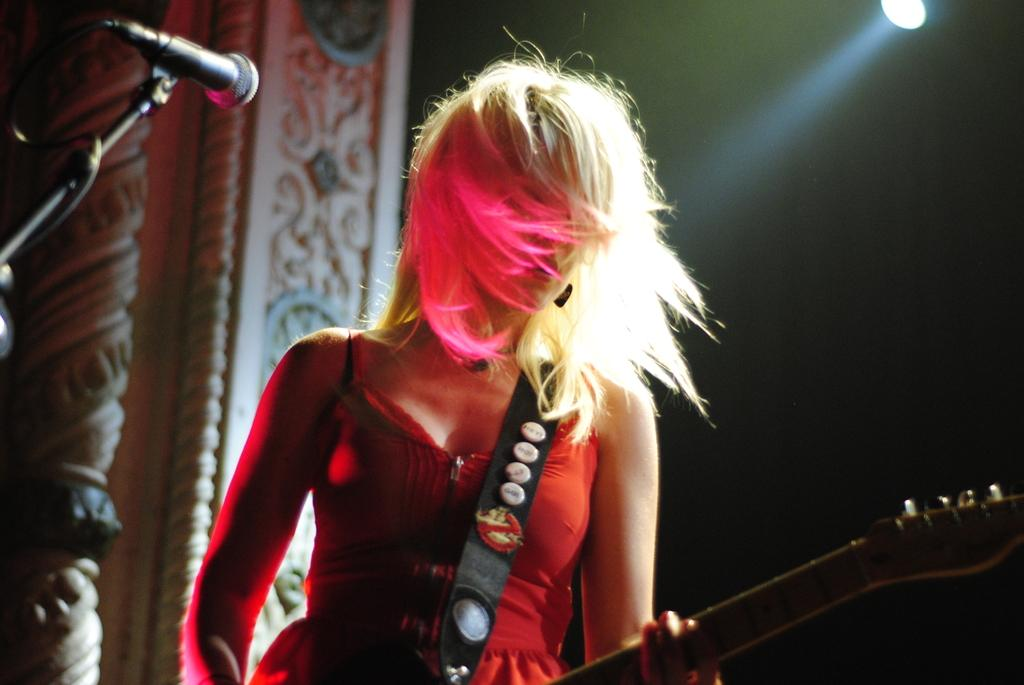Who is the main subject in the image? There is a woman in the image. What is the woman doing in the image? The woman is standing and holding a guitar in her hand. What object is in front of the woman? There is a microphone in front of the woman. What type of yam is the woman holding in the image? There is no yam present in the image; the woman is holding a guitar. What word is the woman singing into the microphone in the image? The image does not show the woman singing or provide any information about the words she might be singing. 